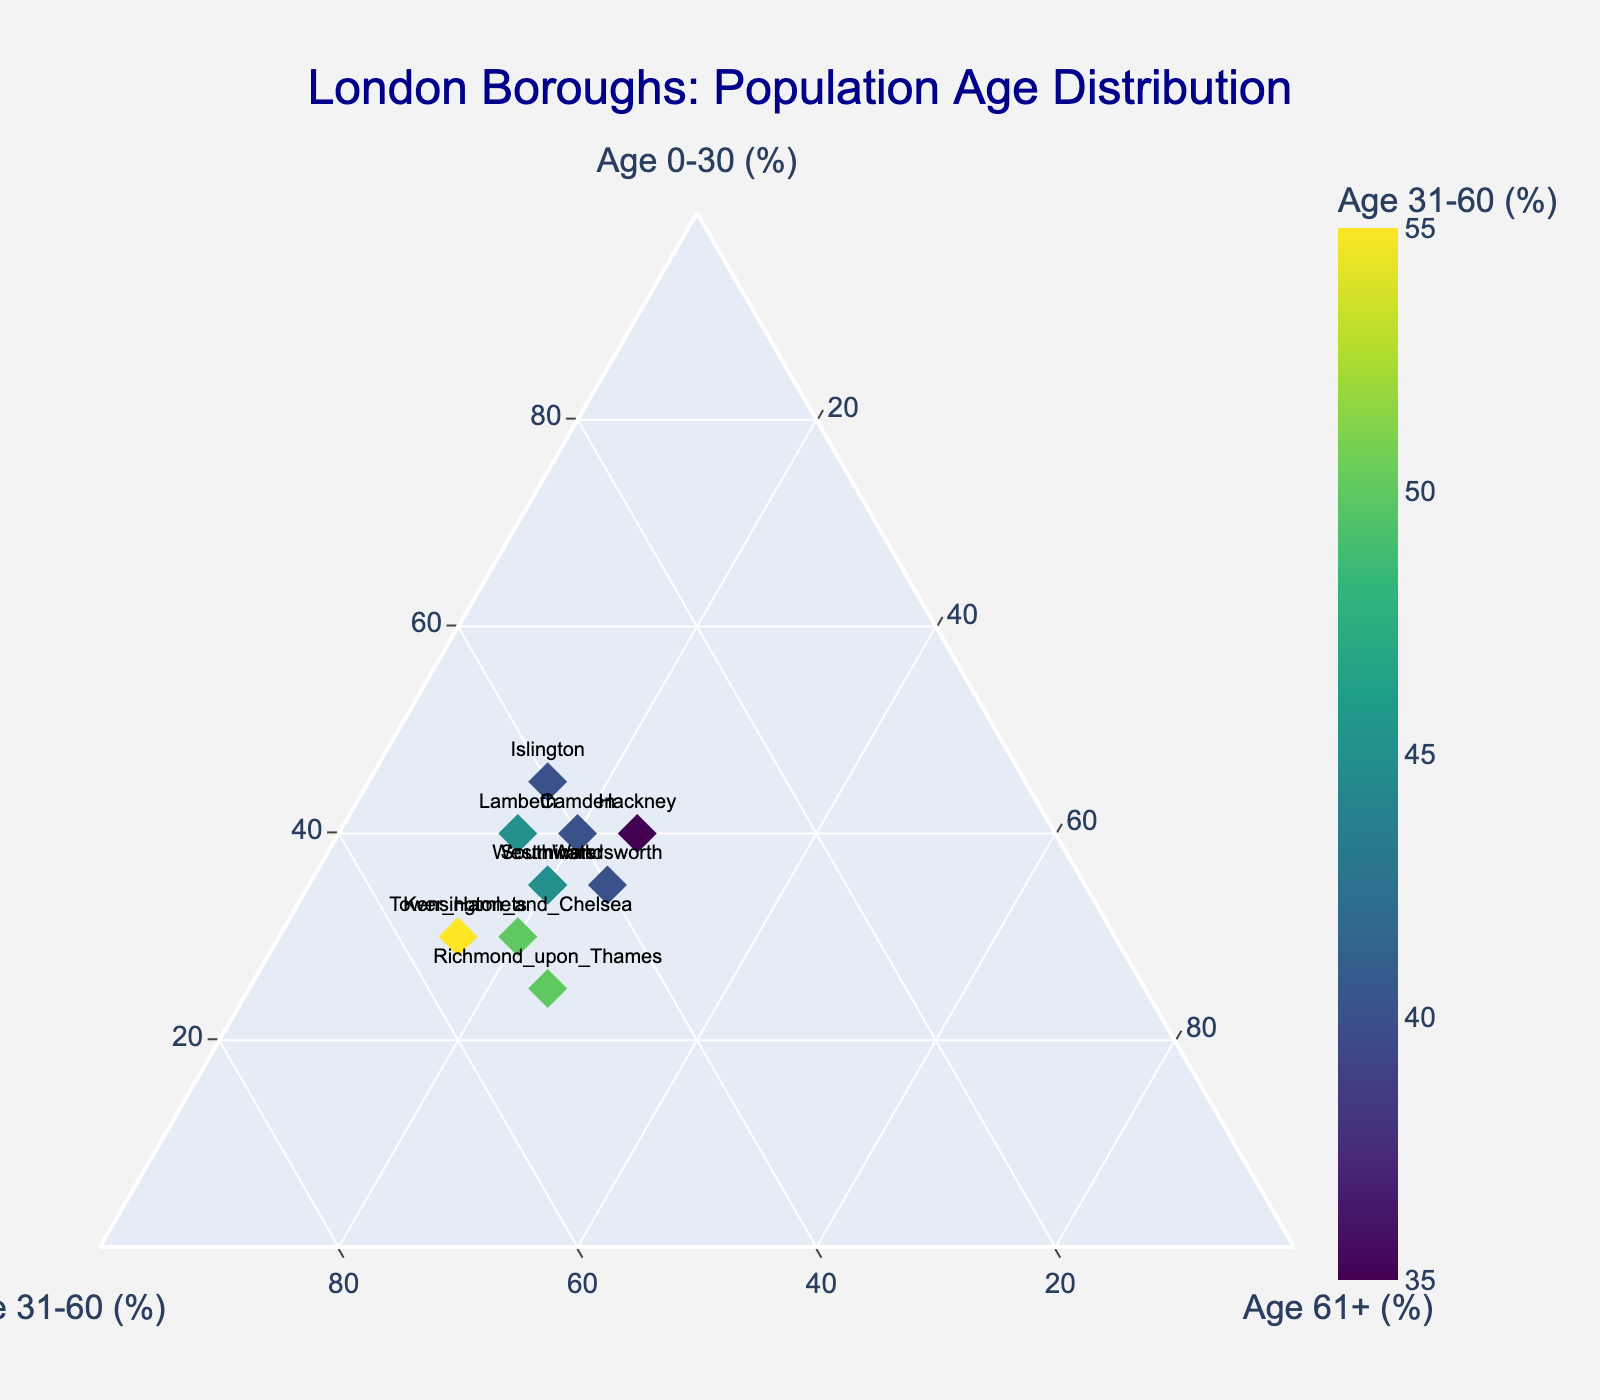What is the title of the plot? The title is typically the largest text at the top of the figure and often central. It describes the main topic or the data being visualized in the plot. From the given data, it is "London Boroughs: Population Age Distribution".
Answer: London Boroughs: Population Age Distribution How many data points are there in the plot? Each borough represents a data point, and we count the number of unique boroughs listed (Westminster, Camden, Kensington_and_Chelsea, Islington, Southwark, Lambeth, Tower_Hamlets, Richmond_upon_Thames, Wandsworth, Hackney). Therefore, we have 10 data points.
Answer: 10 Which borough has the highest percentage of population aged 0-30? To find this, we look at the 'Age_Group_0_30' values and identify the highest value. The maximum value is 45, which corresponds to Islington.
Answer: Islington What is the range of the 'Age 31-60 (%)' values in the plot? The range can be calculated by finding the difference between the maximum and minimum 'Age_Group_31_60' values. The maximum value is 55 (Tower_Hamlets), and the minimum value is 35 (Hackney). So, the range is 55 - 35 = 20.
Answer: 20 Which borough has the smallest percentage of population aged 61+? By examining the 'Age_Group_61_plus' values, we need to find the minimum value. The smallest value is 15, shared by Islington, Lambeth, and Tower_Hamlets.
Answer: Islington, Lambeth, Tower_Hamlets What is the average percentage of population aged 61+ across all boroughs? To find the average, sum up all 'Age_Group_61_plus' values (20+20+20+15+20+15+15+25+25+25 = 200) and divide by the number of boroughs (10). So, the average is 200/10 = 20.
Answer: 20 Which two boroughs have the most similar age distribution? To determine this, compare the percentages of each age group for each borough. By inspection, Westminster and Southwark both have (35%, 45%, 20%) distributions. Therefore, they have identical distributions and are the most similar.
Answer: Westminster and Southwark Which borough has more people aged 0-30 than aged 31-60? Compare the values of 'Age_Group_0_30' and 'Age_Group_31_60' for each borough. No borough satisfies this condition as all have either equal or fewer people aged 0-30 than aged 31-60.
Answer: None What is the distribution trend of boroughs located in central London like Westminster, Camden, and Islington? By inspecting the distribution values for these boroughs, Westminster (35%, 45%, 20%), Camden (40%, 40%, 20%), Islington (45%, 40%, 15%), we notice they generally have a lower population aged 61+ and a relatively balanced distribution between the 0-30 and 31-60 age groups.
Answer: Low 61+, balanced 0-30 & 31-60 